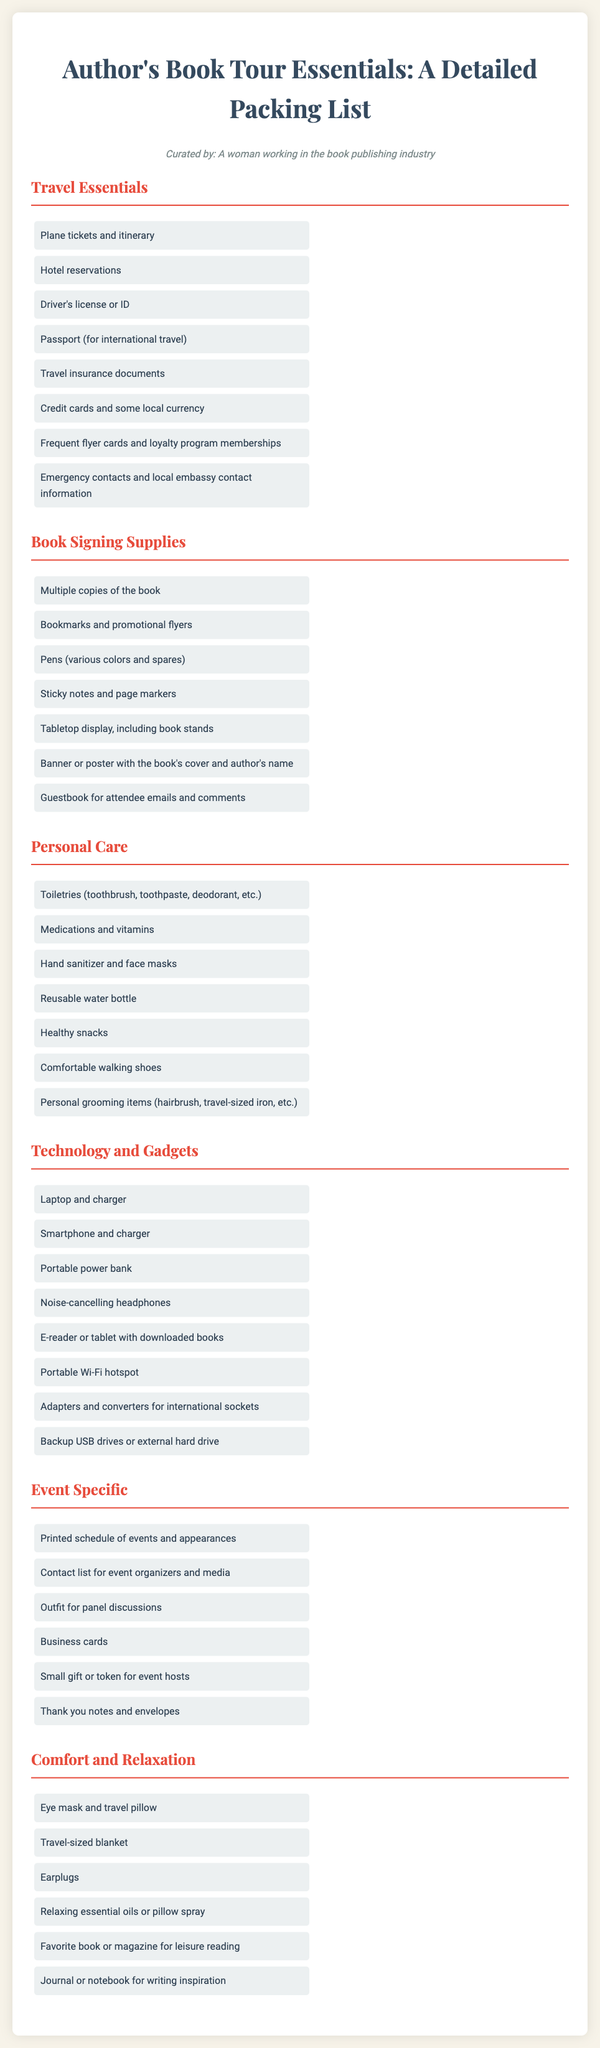What should be included in the travel essentials? The travel essentials list includes items like plane tickets and itinerary, hotel reservations, and a driver's license or ID.
Answer: Plane tickets and itinerary, hotel reservations, and driver's license or ID How many items are listed under Book Signing Supplies? The document lists seven items under Book Signing Supplies.
Answer: Seven What is one item suggested for personal care? The personal care section includes toiletries like a toothbrush and toothpaste among other items.
Answer: Toiletries Which technology item is mentioned for relaxation purposes? The document does not specifically list any technology item for relaxation, but headphones are suggested for noise cancellation, which can contribute to a relaxing environment.
Answer: Noise-cancelling headphones What type of document is this? The packing list details essential items for an author on a book tour, making it a packing list document.
Answer: Packing list What is a suggested comfortable item for travel? The comfort and relaxation section includes items like an eye mask and travel pillow to help ease travel discomfort.
Answer: Eye mask and travel pillow How many event-specific items are included? The event specific section contains six items listed in it.
Answer: Six What type of shoes are recommended? The personal care section suggests wearing comfortable walking shoes, emphasizing the importance of comfort while traveling.
Answer: Comfortable walking shoes 